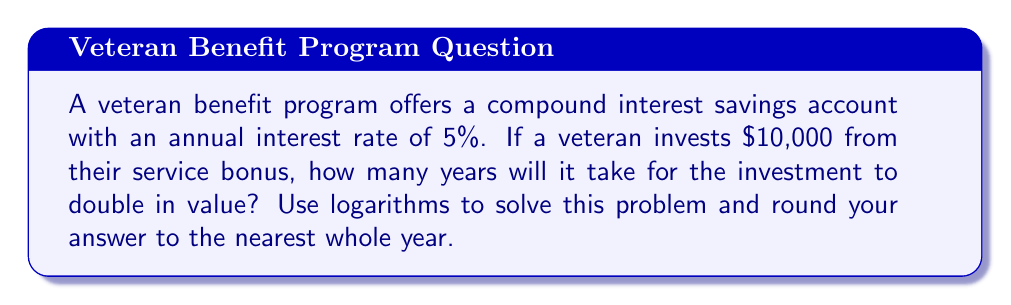Help me with this question. To solve this problem, we'll use the compound interest formula and apply logarithms. Let's break it down step-by-step:

1) The compound interest formula is:
   $$A = P(1 + r)^t$$
   Where:
   $A$ = final amount
   $P$ = principal (initial investment)
   $r$ = annual interest rate (as a decimal)
   $t$ = time in years

2) We want to find when the amount doubles, so:
   $$2P = P(1 + r)^t$$

3) Simplify by dividing both sides by $P$:
   $$2 = (1 + r)^t$$

4) Take the natural logarithm of both sides:
   $$\ln(2) = \ln((1 + r)^t)$$

5) Use the logarithm property $\ln(a^b) = b\ln(a)$:
   $$\ln(2) = t\ln(1 + r)$$

6) Solve for $t$ by dividing both sides by $\ln(1 + r)$:
   $$t = \frac{\ln(2)}{\ln(1 + r)}$$

7) Now, let's plug in our values:
   $r = 0.05$ (5% as a decimal)

   $$t = \frac{\ln(2)}{\ln(1 + 0.05)} = \frac{\ln(2)}{\ln(1.05)}$$

8) Calculate:
   $$t \approx 14.2067$$

9) Rounding to the nearest whole year:
   $t = 14$ years
Answer: 14 years 